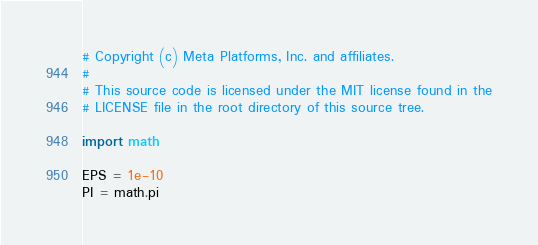Convert code to text. <code><loc_0><loc_0><loc_500><loc_500><_Python_># Copyright (c) Meta Platforms, Inc. and affiliates.
#
# This source code is licensed under the MIT license found in the
# LICENSE file in the root directory of this source tree.

import math

EPS = 1e-10
PI = math.pi
</code> 